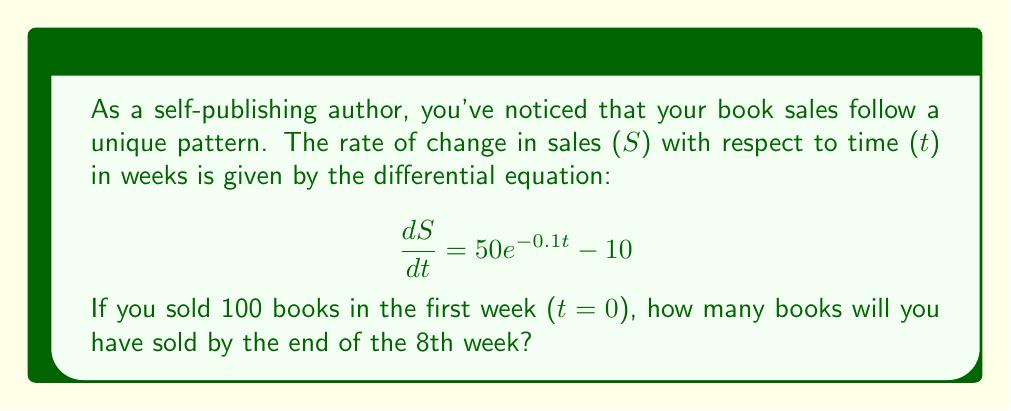Give your solution to this math problem. To solve this problem, we need to follow these steps:

1) First, we need to solve the differential equation to find S(t).

2) The general solution to this differential equation is:

   $$ S(t) = -500e^{-0.1t} - 10t + C $$

   Where C is a constant of integration.

3) We can find C using the initial condition: S(0) = 100

   $$ 100 = -500e^0 - 10(0) + C $$
   $$ 100 = -500 + C $$
   $$ C = 600 $$

4) So, the particular solution is:

   $$ S(t) = -500e^{-0.1t} - 10t + 600 $$

5) To find the number of books sold by the end of the 8th week, we need to calculate S(8):

   $$ S(8) = -500e^{-0.1(8)} - 10(8) + 600 $$
   $$ = -500e^{-0.8} - 80 + 600 $$
   $$ \approx -225.74 - 80 + 600 $$
   $$ \approx 294.26 $$

6) Since we can't sell a fraction of a book, we round down to the nearest whole number.
Answer: By the end of the 8th week, you will have sold 294 books. 